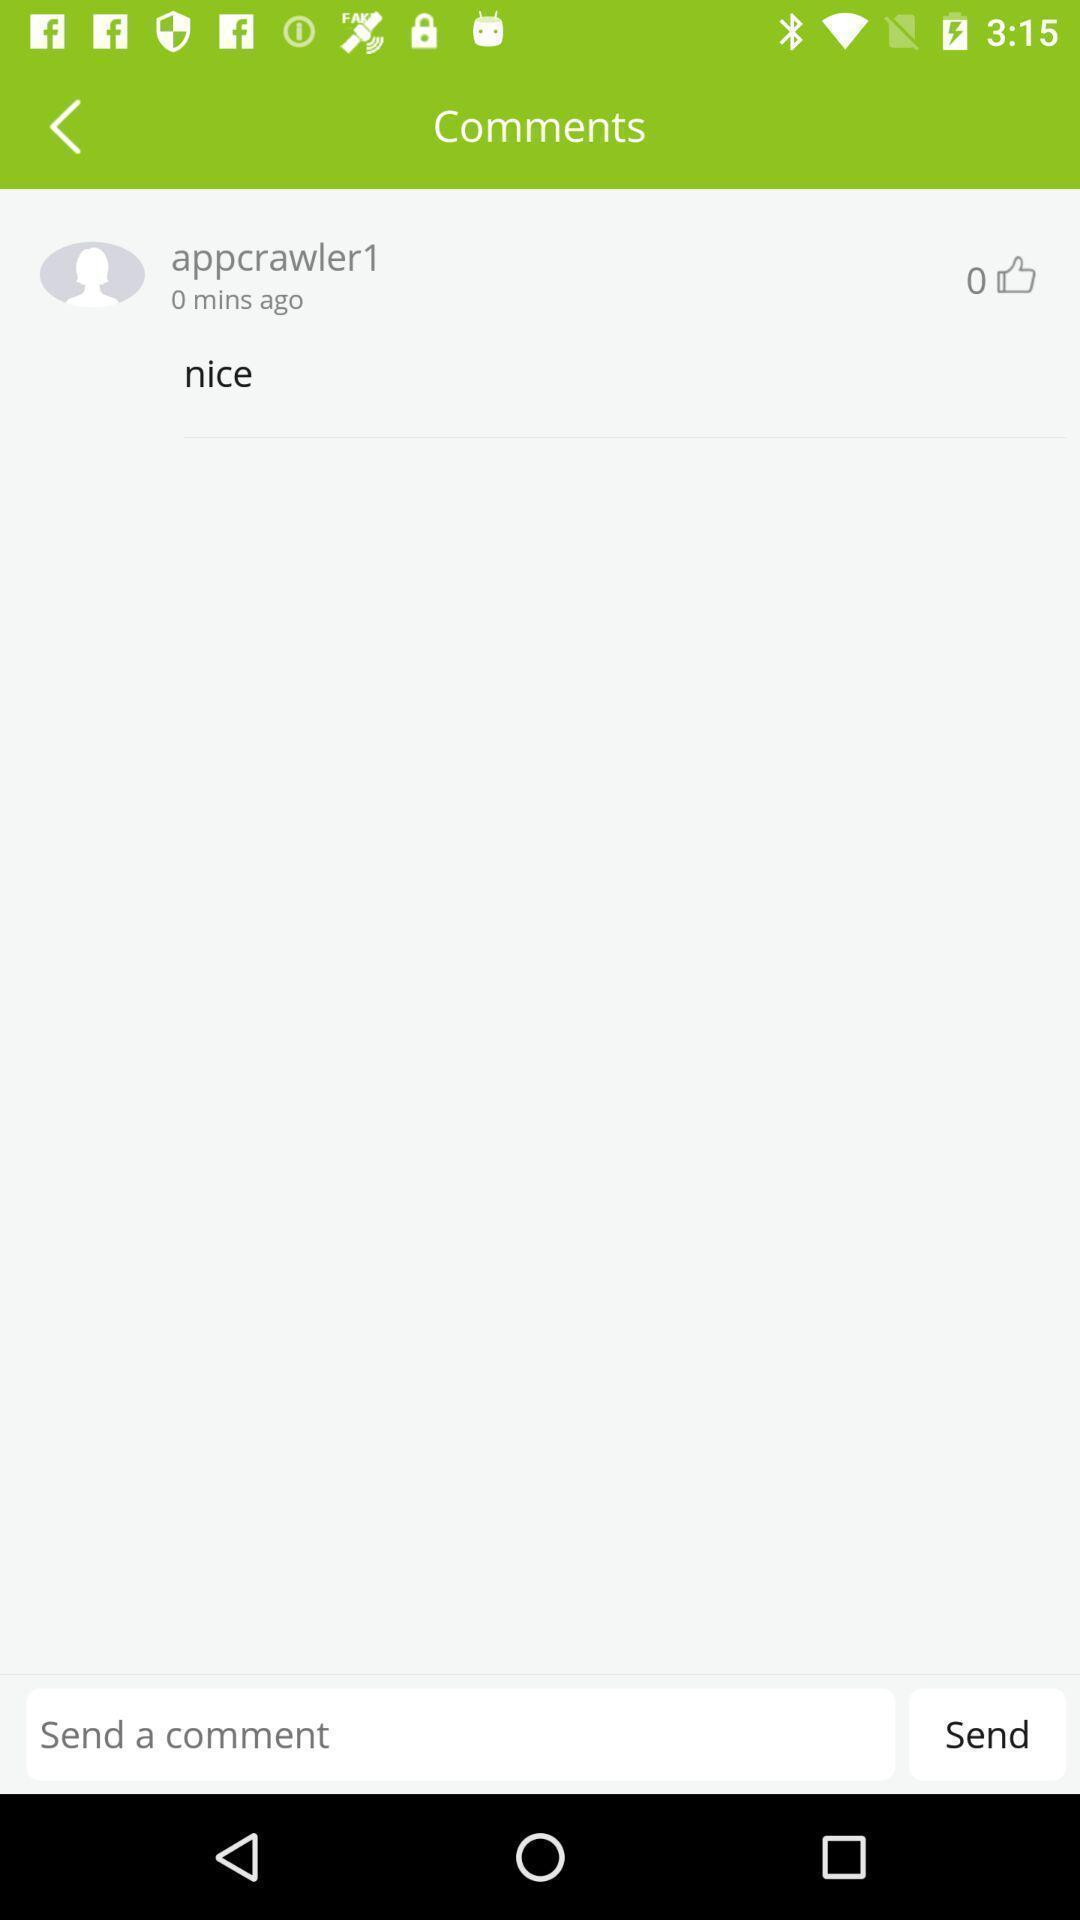Tell me what you see in this picture. Page displaying the comment section. 